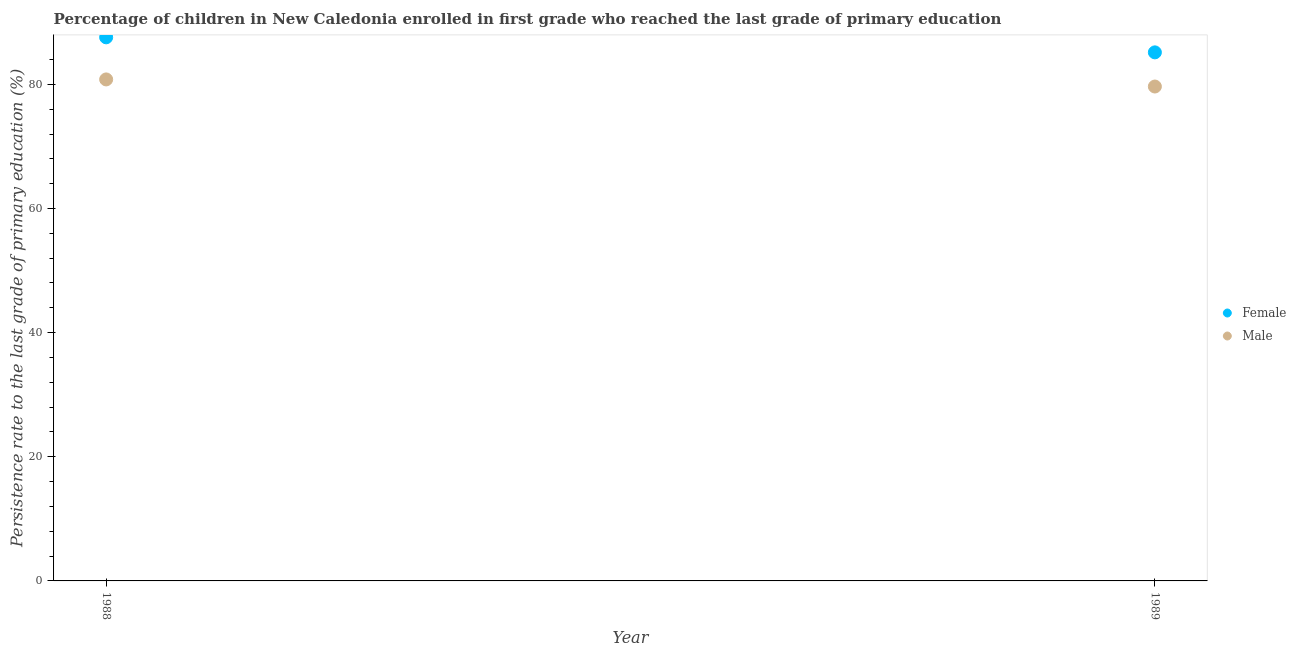What is the persistence rate of male students in 1989?
Make the answer very short. 79.65. Across all years, what is the maximum persistence rate of male students?
Ensure brevity in your answer.  80.8. Across all years, what is the minimum persistence rate of female students?
Offer a very short reply. 85.16. In which year was the persistence rate of female students maximum?
Keep it short and to the point. 1988. What is the total persistence rate of female students in the graph?
Provide a short and direct response. 172.74. What is the difference between the persistence rate of male students in 1988 and that in 1989?
Provide a succinct answer. 1.14. What is the difference between the persistence rate of male students in 1989 and the persistence rate of female students in 1988?
Your answer should be very brief. -7.92. What is the average persistence rate of male students per year?
Your response must be concise. 80.23. In the year 1988, what is the difference between the persistence rate of male students and persistence rate of female students?
Provide a succinct answer. -6.78. In how many years, is the persistence rate of female students greater than 4 %?
Provide a short and direct response. 2. What is the ratio of the persistence rate of female students in 1988 to that in 1989?
Your answer should be compact. 1.03. In how many years, is the persistence rate of male students greater than the average persistence rate of male students taken over all years?
Give a very brief answer. 1. Is the persistence rate of male students strictly less than the persistence rate of female students over the years?
Make the answer very short. Yes. How many years are there in the graph?
Ensure brevity in your answer.  2. Does the graph contain any zero values?
Provide a short and direct response. No. Does the graph contain grids?
Your answer should be very brief. No. How are the legend labels stacked?
Keep it short and to the point. Vertical. What is the title of the graph?
Offer a very short reply. Percentage of children in New Caledonia enrolled in first grade who reached the last grade of primary education. What is the label or title of the X-axis?
Ensure brevity in your answer.  Year. What is the label or title of the Y-axis?
Keep it short and to the point. Persistence rate to the last grade of primary education (%). What is the Persistence rate to the last grade of primary education (%) in Female in 1988?
Your response must be concise. 87.58. What is the Persistence rate to the last grade of primary education (%) in Male in 1988?
Your answer should be very brief. 80.8. What is the Persistence rate to the last grade of primary education (%) of Female in 1989?
Give a very brief answer. 85.16. What is the Persistence rate to the last grade of primary education (%) in Male in 1989?
Your answer should be very brief. 79.65. Across all years, what is the maximum Persistence rate to the last grade of primary education (%) of Female?
Offer a very short reply. 87.58. Across all years, what is the maximum Persistence rate to the last grade of primary education (%) of Male?
Your answer should be very brief. 80.8. Across all years, what is the minimum Persistence rate to the last grade of primary education (%) in Female?
Make the answer very short. 85.16. Across all years, what is the minimum Persistence rate to the last grade of primary education (%) in Male?
Your answer should be very brief. 79.65. What is the total Persistence rate to the last grade of primary education (%) in Female in the graph?
Your response must be concise. 172.74. What is the total Persistence rate to the last grade of primary education (%) of Male in the graph?
Your answer should be very brief. 160.45. What is the difference between the Persistence rate to the last grade of primary education (%) in Female in 1988 and that in 1989?
Keep it short and to the point. 2.42. What is the difference between the Persistence rate to the last grade of primary education (%) in Male in 1988 and that in 1989?
Your answer should be compact. 1.14. What is the difference between the Persistence rate to the last grade of primary education (%) of Female in 1988 and the Persistence rate to the last grade of primary education (%) of Male in 1989?
Offer a terse response. 7.92. What is the average Persistence rate to the last grade of primary education (%) of Female per year?
Your response must be concise. 86.37. What is the average Persistence rate to the last grade of primary education (%) in Male per year?
Keep it short and to the point. 80.23. In the year 1988, what is the difference between the Persistence rate to the last grade of primary education (%) in Female and Persistence rate to the last grade of primary education (%) in Male?
Make the answer very short. 6.78. In the year 1989, what is the difference between the Persistence rate to the last grade of primary education (%) of Female and Persistence rate to the last grade of primary education (%) of Male?
Provide a succinct answer. 5.5. What is the ratio of the Persistence rate to the last grade of primary education (%) of Female in 1988 to that in 1989?
Keep it short and to the point. 1.03. What is the ratio of the Persistence rate to the last grade of primary education (%) of Male in 1988 to that in 1989?
Make the answer very short. 1.01. What is the difference between the highest and the second highest Persistence rate to the last grade of primary education (%) of Female?
Offer a terse response. 2.42. What is the difference between the highest and the second highest Persistence rate to the last grade of primary education (%) in Male?
Provide a short and direct response. 1.14. What is the difference between the highest and the lowest Persistence rate to the last grade of primary education (%) in Female?
Give a very brief answer. 2.42. What is the difference between the highest and the lowest Persistence rate to the last grade of primary education (%) of Male?
Provide a succinct answer. 1.14. 